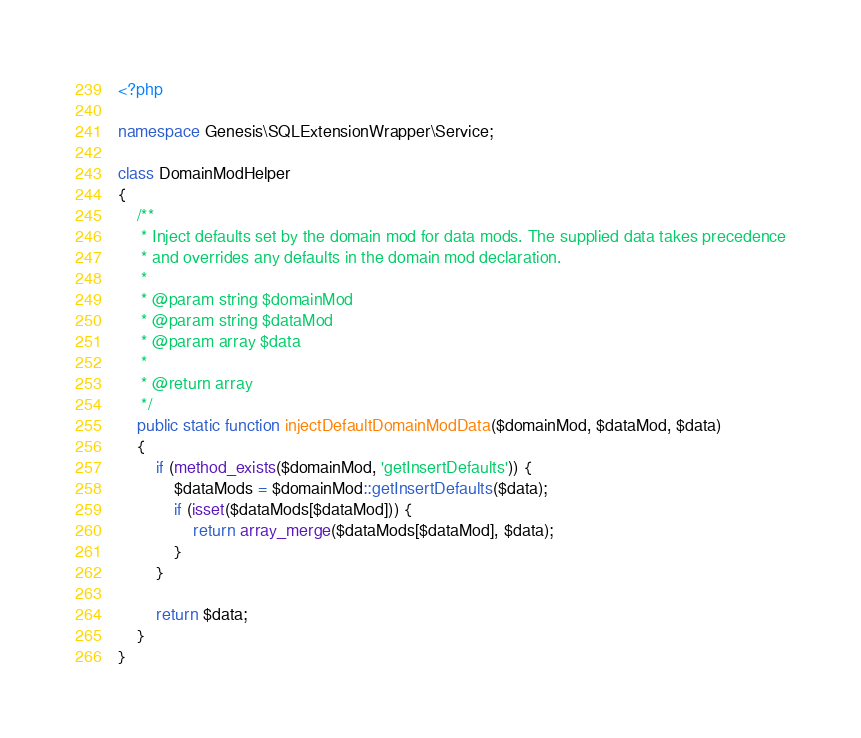<code> <loc_0><loc_0><loc_500><loc_500><_PHP_><?php

namespace Genesis\SQLExtensionWrapper\Service;

class DomainModHelper
{
    /**
     * Inject defaults set by the domain mod for data mods. The supplied data takes precedence
     * and overrides any defaults in the domain mod declaration.
     *
     * @param string $domainMod
     * @param string $dataMod
     * @param array $data
     *
     * @return array
     */
    public static function injectDefaultDomainModData($domainMod, $dataMod, $data)
    {
        if (method_exists($domainMod, 'getInsertDefaults')) {
            $dataMods = $domainMod::getInsertDefaults($data);
            if (isset($dataMods[$dataMod])) {
                return array_merge($dataMods[$dataMod], $data);
            }
        }

        return $data;
    }
}
</code> 